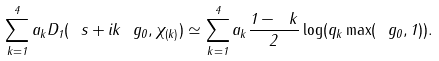Convert formula to latex. <formula><loc_0><loc_0><loc_500><loc_500>\sum _ { k = 1 } ^ { 4 } a _ { k } D _ { 1 } ( \ s + i k \ g _ { 0 } , \chi _ { ( k ) } ) \simeq \sum _ { k = 1 } ^ { 4 } a _ { k } \frac { 1 - \ k } { 2 } \log ( q _ { k } \max ( \ g _ { 0 } , 1 ) ) .</formula> 